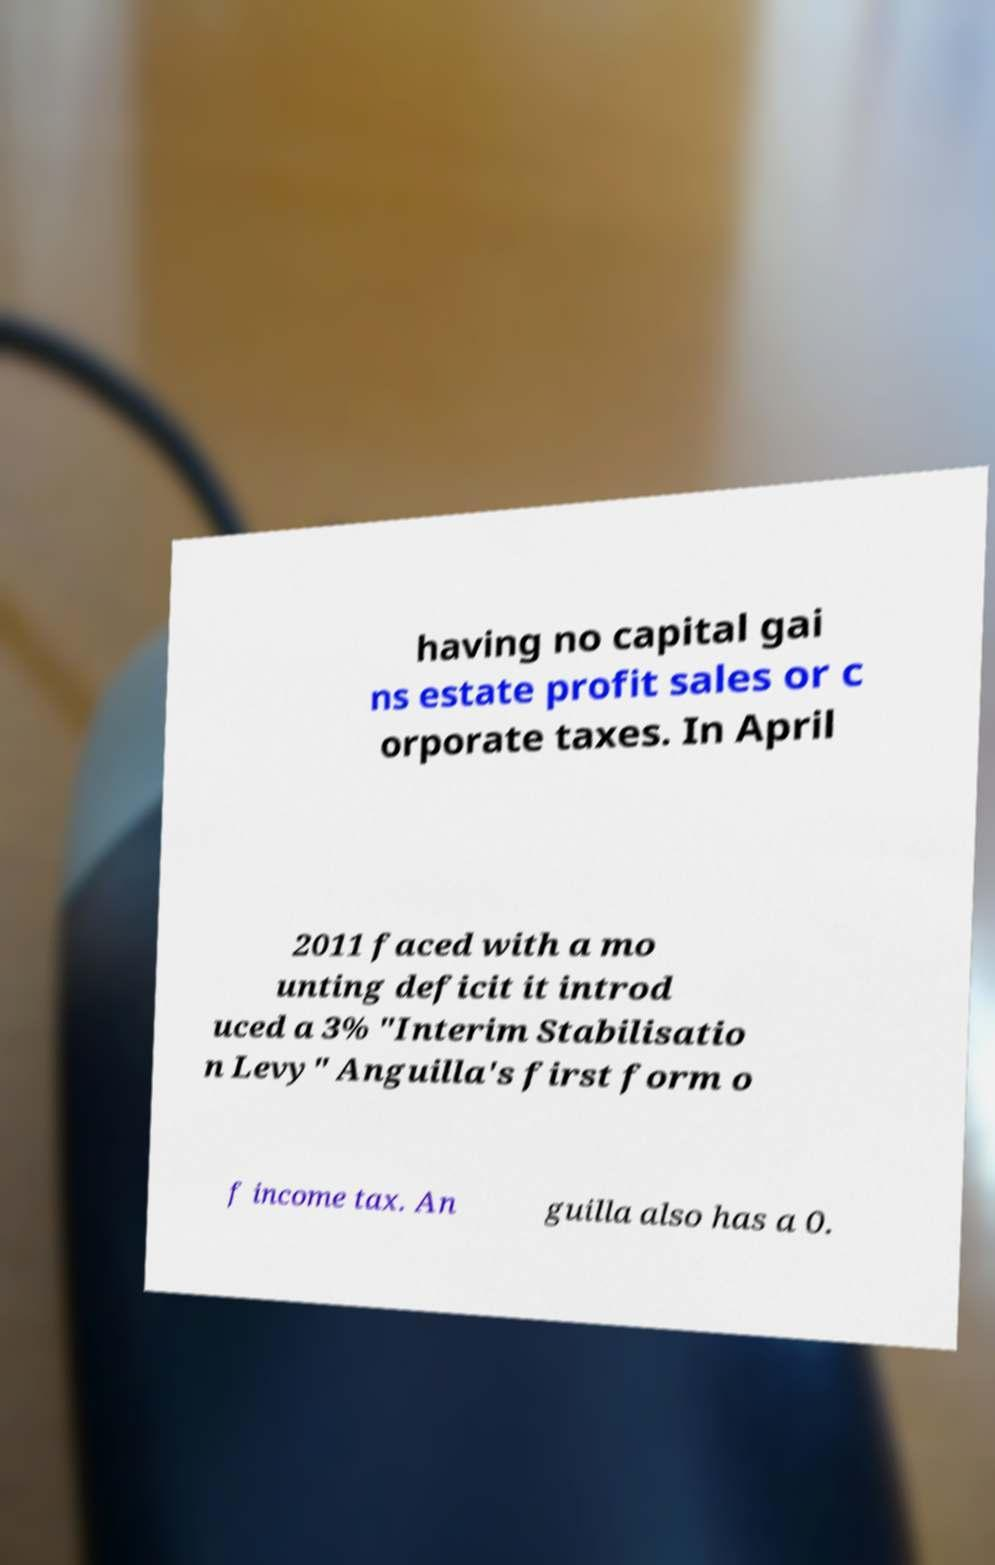Could you assist in decoding the text presented in this image and type it out clearly? having no capital gai ns estate profit sales or c orporate taxes. In April 2011 faced with a mo unting deficit it introd uced a 3% "Interim Stabilisatio n Levy" Anguilla's first form o f income tax. An guilla also has a 0. 